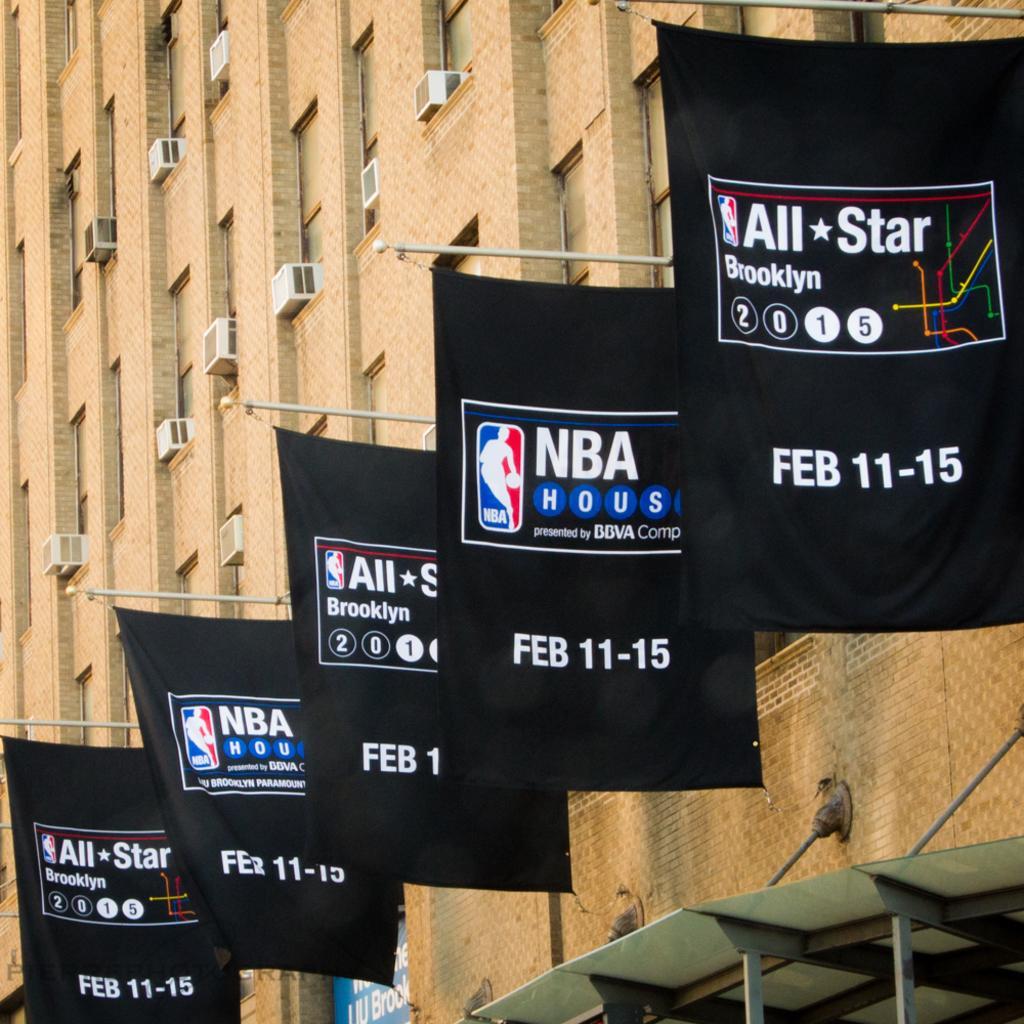How would you summarize this image in a sentence or two? This picture shows a tall building and we see few advertisement banners hanging to the building and we see few AC compressors. 